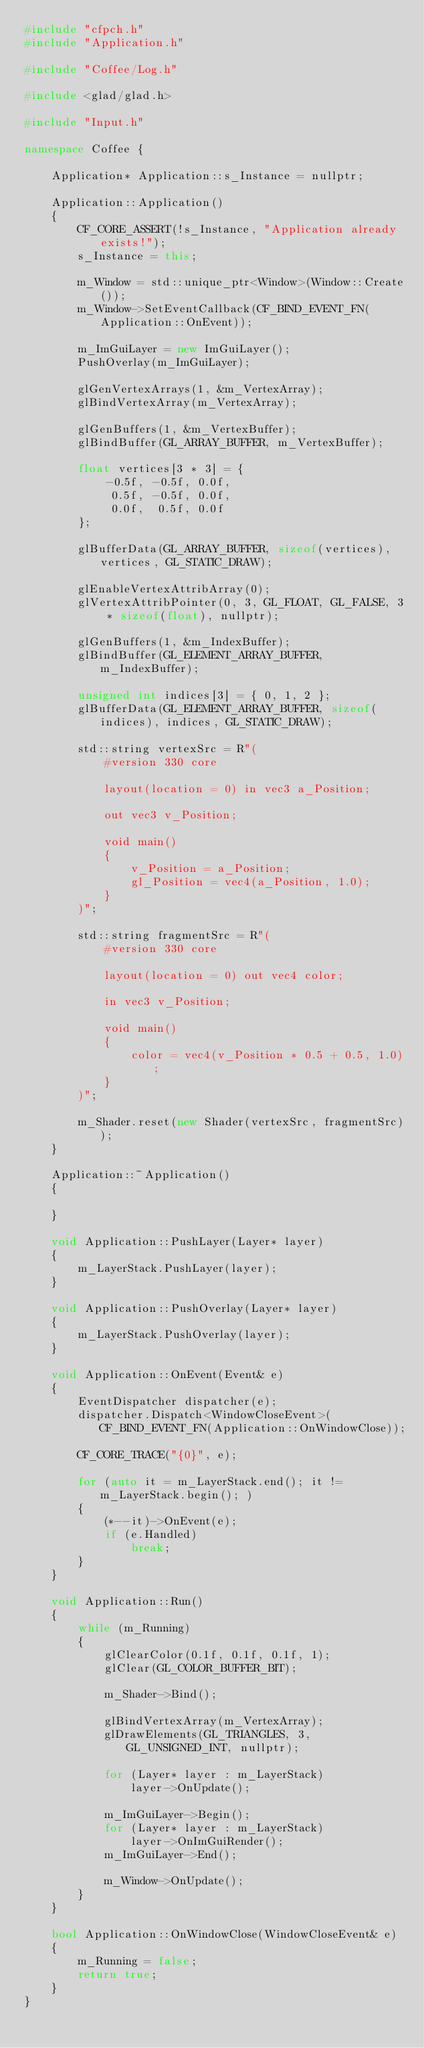Convert code to text. <code><loc_0><loc_0><loc_500><loc_500><_C++_>#include "cfpch.h"
#include "Application.h"

#include "Coffee/Log.h"

#include <glad/glad.h>

#include "Input.h"

namespace Coffee {

	Application* Application::s_Instance = nullptr;

	Application::Application()
	{
		CF_CORE_ASSERT(!s_Instance, "Application already exists!");
		s_Instance = this;

		m_Window = std::unique_ptr<Window>(Window::Create());
		m_Window->SetEventCallback(CF_BIND_EVENT_FN(Application::OnEvent));

		m_ImGuiLayer = new ImGuiLayer();
		PushOverlay(m_ImGuiLayer);

		glGenVertexArrays(1, &m_VertexArray);
		glBindVertexArray(m_VertexArray);

		glGenBuffers(1, &m_VertexBuffer);
		glBindBuffer(GL_ARRAY_BUFFER, m_VertexBuffer);

		float vertices[3 * 3] = {
			-0.5f, -0.5f, 0.0f,
			 0.5f, -0.5f, 0.0f,
			 0.0f,  0.5f, 0.0f
		};

		glBufferData(GL_ARRAY_BUFFER, sizeof(vertices), vertices, GL_STATIC_DRAW);

		glEnableVertexAttribArray(0);
		glVertexAttribPointer(0, 3, GL_FLOAT, GL_FALSE, 3 * sizeof(float), nullptr);

		glGenBuffers(1, &m_IndexBuffer);
		glBindBuffer(GL_ELEMENT_ARRAY_BUFFER, m_IndexBuffer);

		unsigned int indices[3] = { 0, 1, 2 };
		glBufferData(GL_ELEMENT_ARRAY_BUFFER, sizeof(indices), indices, GL_STATIC_DRAW);

		std::string vertexSrc = R"(
			#version 330 core
			
			layout(location = 0) in vec3 a_Position;

			out vec3 v_Position;

			void main()
			{
				v_Position = a_Position;
				gl_Position = vec4(a_Position, 1.0);	
			}
		)";

		std::string fragmentSrc = R"(
			#version 330 core
			
			layout(location = 0) out vec4 color;

			in vec3 v_Position;

			void main()
			{
				color = vec4(v_Position * 0.5 + 0.5, 1.0);
			}
		)";

		m_Shader.reset(new Shader(vertexSrc, fragmentSrc));
	}
	
	Application::~Application()
	{

	}
	
	void Application::PushLayer(Layer* layer)
	{
		m_LayerStack.PushLayer(layer);
	}

	void Application::PushOverlay(Layer* layer)
	{
		m_LayerStack.PushOverlay(layer);
	}

	void Application::OnEvent(Event& e)
	{
		EventDispatcher dispatcher(e);
		dispatcher.Dispatch<WindowCloseEvent>(CF_BIND_EVENT_FN(Application::OnWindowClose));
		
		CF_CORE_TRACE("{0}", e);

		for (auto it = m_LayerStack.end(); it != m_LayerStack.begin(); )
		{
			(*--it)->OnEvent(e);
			if (e.Handled)
				break;
		}
	}

	void Application::Run()
	{
		while (m_Running)
		{
			glClearColor(0.1f, 0.1f, 0.1f, 1);
			glClear(GL_COLOR_BUFFER_BIT);

			m_Shader->Bind();

			glBindVertexArray(m_VertexArray);
			glDrawElements(GL_TRIANGLES, 3, GL_UNSIGNED_INT, nullptr);

			for (Layer* layer : m_LayerStack)
				layer->OnUpdate();

			m_ImGuiLayer->Begin();
			for (Layer* layer : m_LayerStack)
				layer->OnImGuiRender();
			m_ImGuiLayer->End();

			m_Window->OnUpdate();
		}
	}

	bool Application::OnWindowClose(WindowCloseEvent& e)
	{
		m_Running = false;
		return true;
	}
}
</code> 